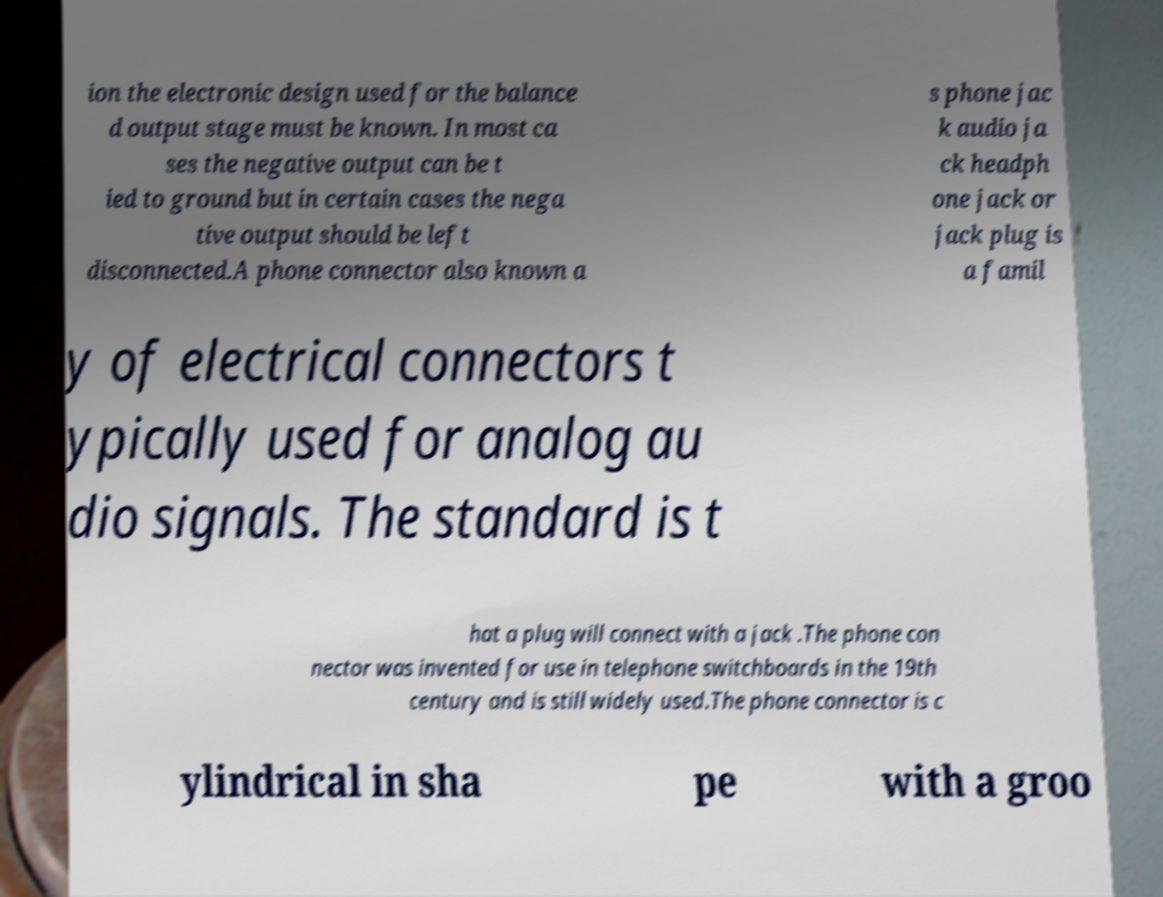Please read and relay the text visible in this image. What does it say? ion the electronic design used for the balance d output stage must be known. In most ca ses the negative output can be t ied to ground but in certain cases the nega tive output should be left disconnected.A phone connector also known a s phone jac k audio ja ck headph one jack or jack plug is a famil y of electrical connectors t ypically used for analog au dio signals. The standard is t hat a plug will connect with a jack .The phone con nector was invented for use in telephone switchboards in the 19th century and is still widely used.The phone connector is c ylindrical in sha pe with a groo 